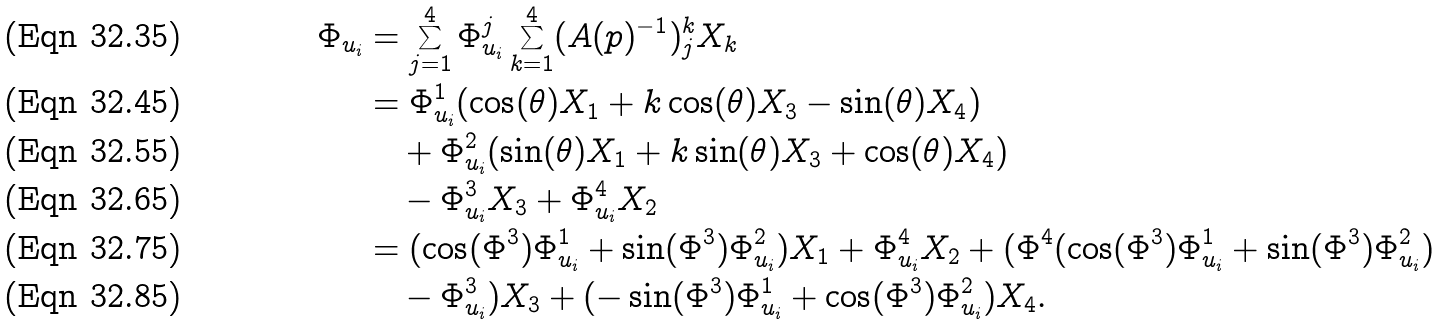<formula> <loc_0><loc_0><loc_500><loc_500>\Phi _ { u _ { i } } & = \sum _ { j = 1 } ^ { 4 } \Phi _ { u _ { i } } ^ { j } \sum _ { k = 1 } ^ { 4 } ( A ( p ) ^ { - 1 } ) _ { j } ^ { k } X _ { k } \\ & = \Phi _ { u _ { i } } ^ { 1 } ( \cos ( \theta ) X _ { 1 } + k \cos ( \theta ) X _ { 3 } - \sin ( \theta ) X _ { 4 } ) \\ & \quad + \Phi _ { u _ { i } } ^ { 2 } ( \sin ( \theta ) X _ { 1 } + k \sin ( \theta ) X _ { 3 } + \cos ( \theta ) X _ { 4 } ) \\ & \quad - \Phi _ { u _ { i } } ^ { 3 } X _ { 3 } + \Phi _ { u _ { i } } ^ { 4 } X _ { 2 } \\ & = ( \cos ( \Phi ^ { 3 } ) \Phi _ { u _ { i } } ^ { 1 } + \sin ( \Phi ^ { 3 } ) \Phi _ { u _ { i } } ^ { 2 } ) X _ { 1 } + \Phi _ { u _ { i } } ^ { 4 } X _ { 2 } + ( \Phi ^ { 4 } ( \cos ( \Phi ^ { 3 } ) \Phi _ { u _ { i } } ^ { 1 } + \sin ( \Phi ^ { 3 } ) \Phi _ { u _ { i } } ^ { 2 } ) \\ & \quad - \Phi _ { u _ { i } } ^ { 3 } ) X _ { 3 } + ( - \sin ( \Phi ^ { 3 } ) \Phi _ { u _ { i } } ^ { 1 } + \cos ( \Phi ^ { 3 } ) \Phi _ { u _ { i } } ^ { 2 } ) X _ { 4 } .</formula> 